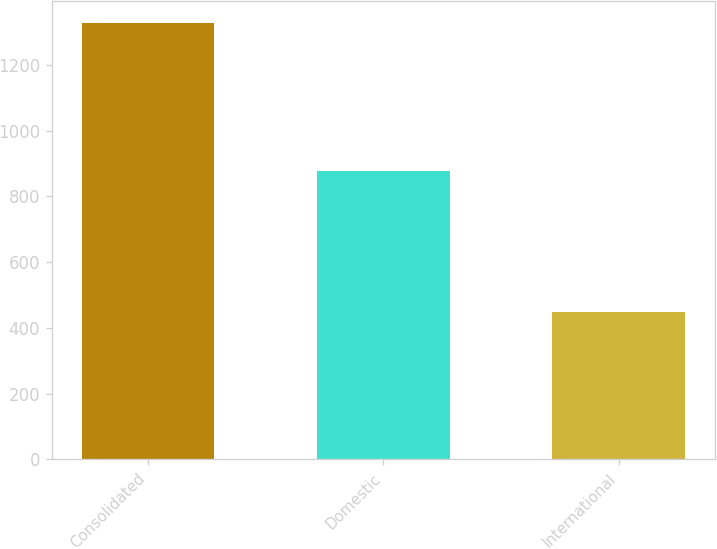Convert chart to OTSL. <chart><loc_0><loc_0><loc_500><loc_500><bar_chart><fcel>Consolidated<fcel>Domestic<fcel>International<nl><fcel>1326.7<fcel>878.6<fcel>448.1<nl></chart> 